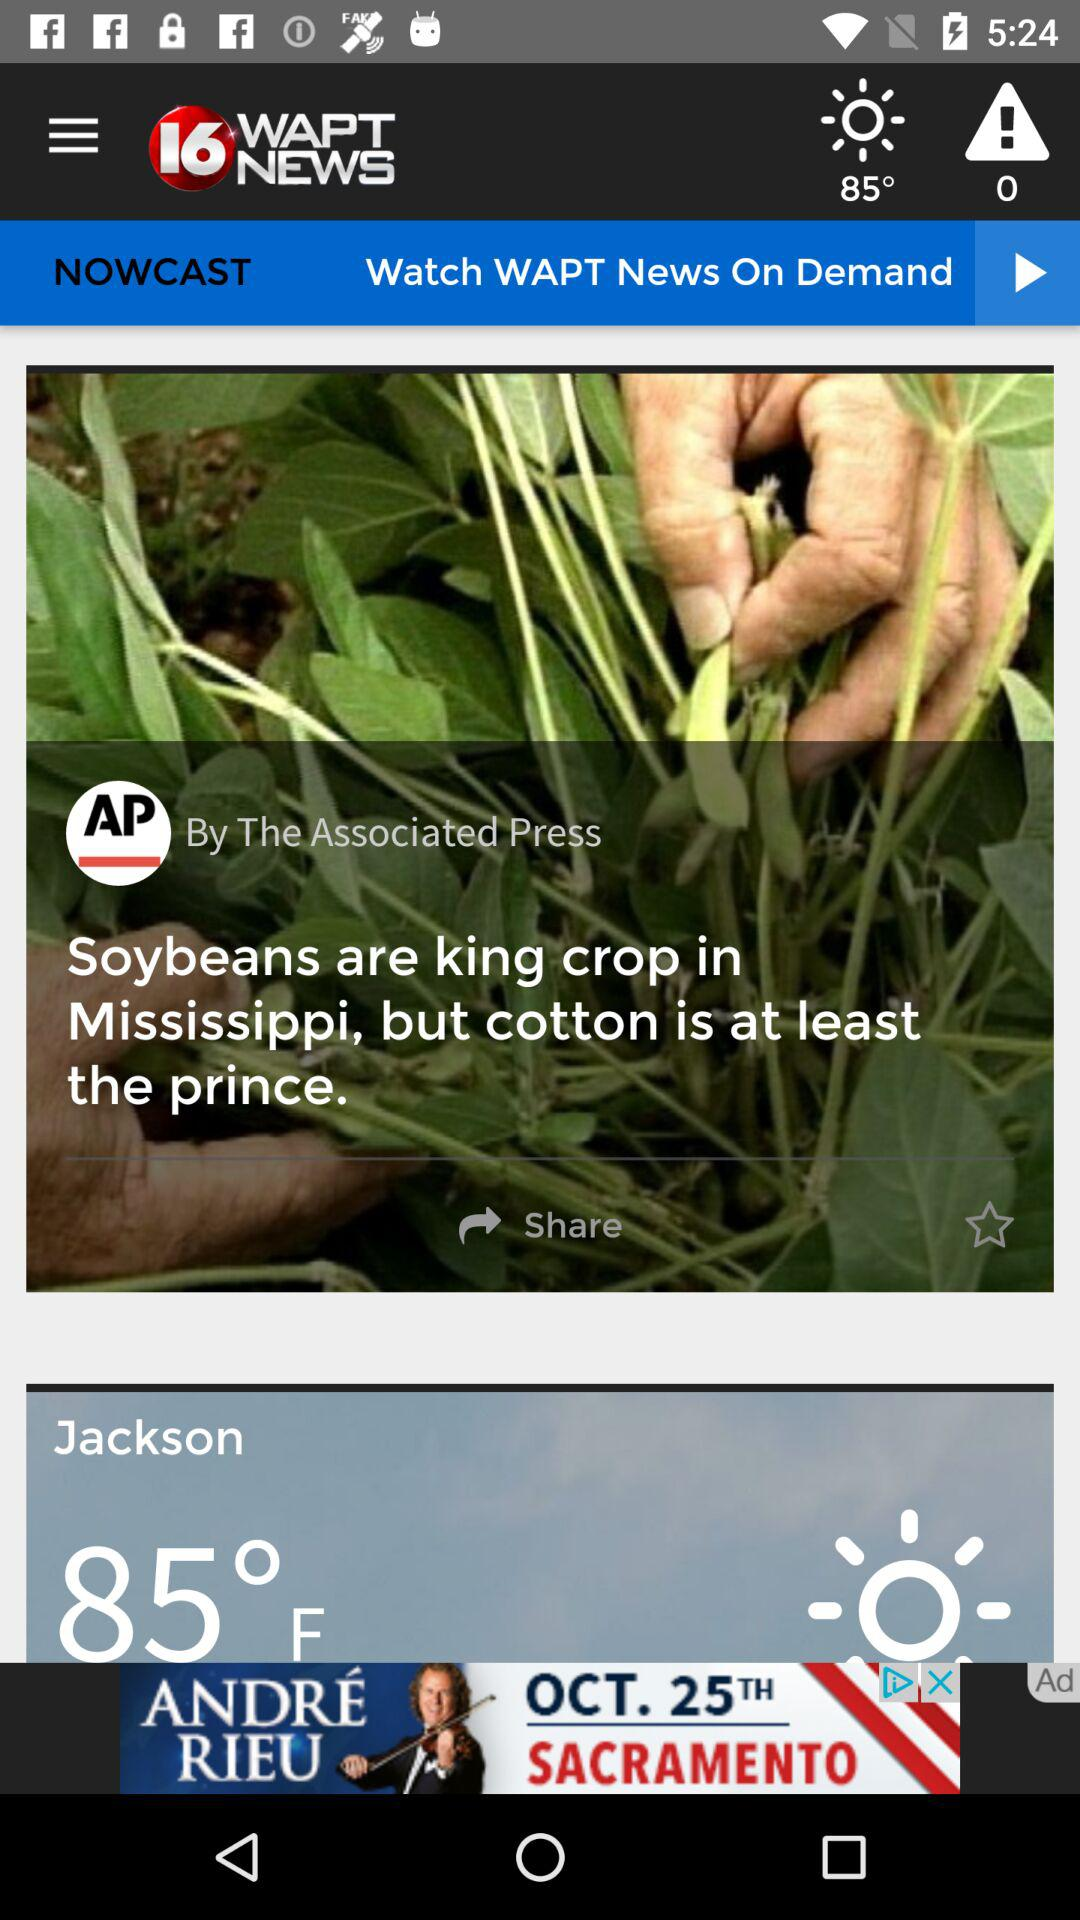How many alert notifications are there? There are 0 alert notifications. 